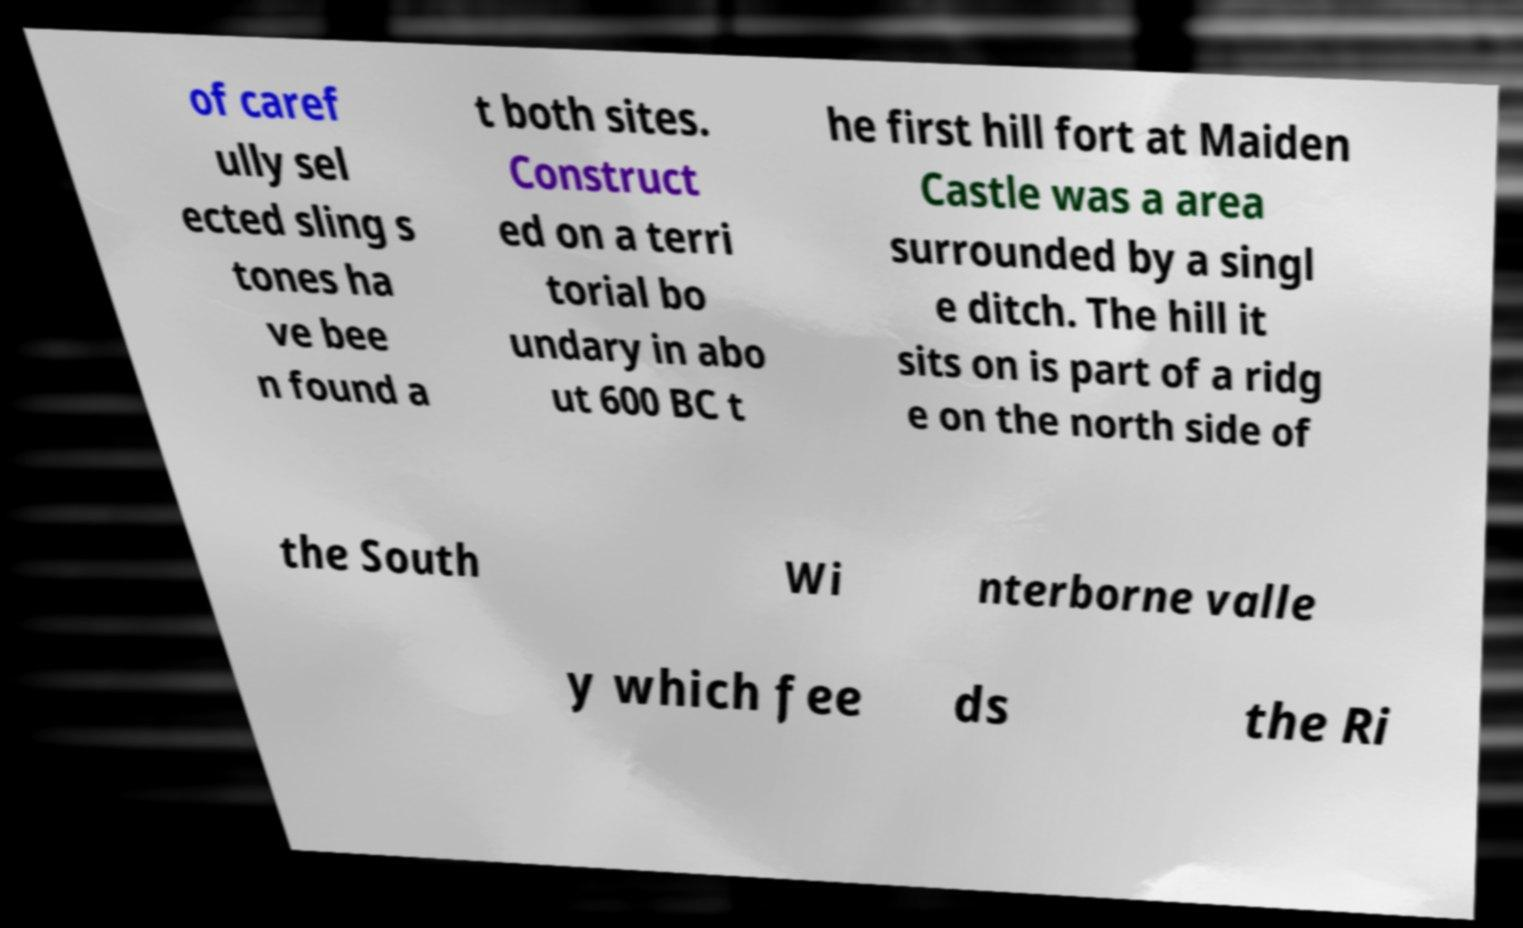Please identify and transcribe the text found in this image. of caref ully sel ected sling s tones ha ve bee n found a t both sites. Construct ed on a terri torial bo undary in abo ut 600 BC t he first hill fort at Maiden Castle was a area surrounded by a singl e ditch. The hill it sits on is part of a ridg e on the north side of the South Wi nterborne valle y which fee ds the Ri 